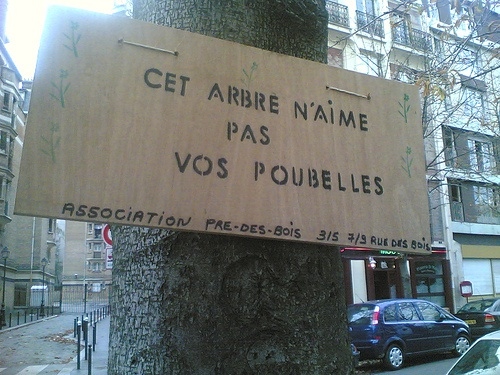Describe the objects in this image and their specific colors. I can see car in lavender, black, navy, blue, and gray tones, car in lavender, teal, and lightblue tones, and car in lavender, black, and teal tones in this image. 